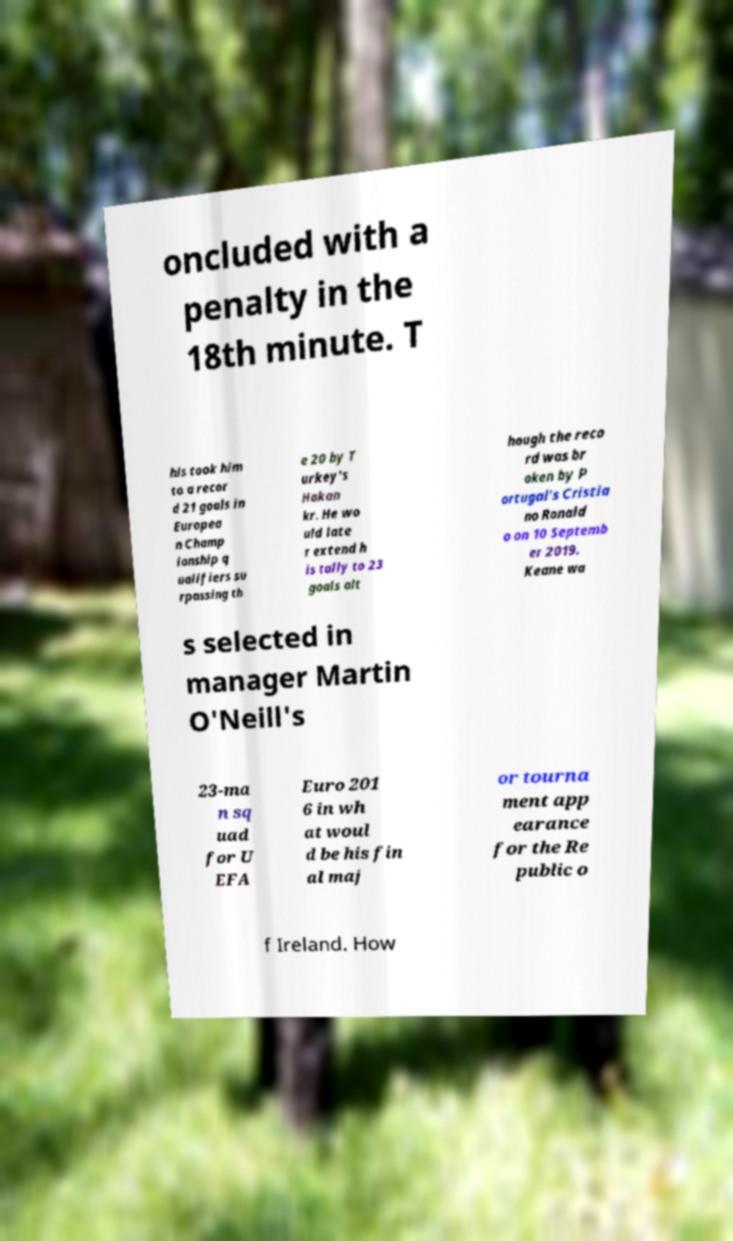Can you read and provide the text displayed in the image?This photo seems to have some interesting text. Can you extract and type it out for me? oncluded with a penalty in the 18th minute. T his took him to a recor d 21 goals in Europea n Champ ionship q ualifiers su rpassing th e 20 by T urkey's Hakan kr. He wo uld late r extend h is tally to 23 goals alt hough the reco rd was br oken by P ortugal's Cristia no Ronald o on 10 Septemb er 2019. Keane wa s selected in manager Martin O'Neill's 23-ma n sq uad for U EFA Euro 201 6 in wh at woul d be his fin al maj or tourna ment app earance for the Re public o f Ireland. How 